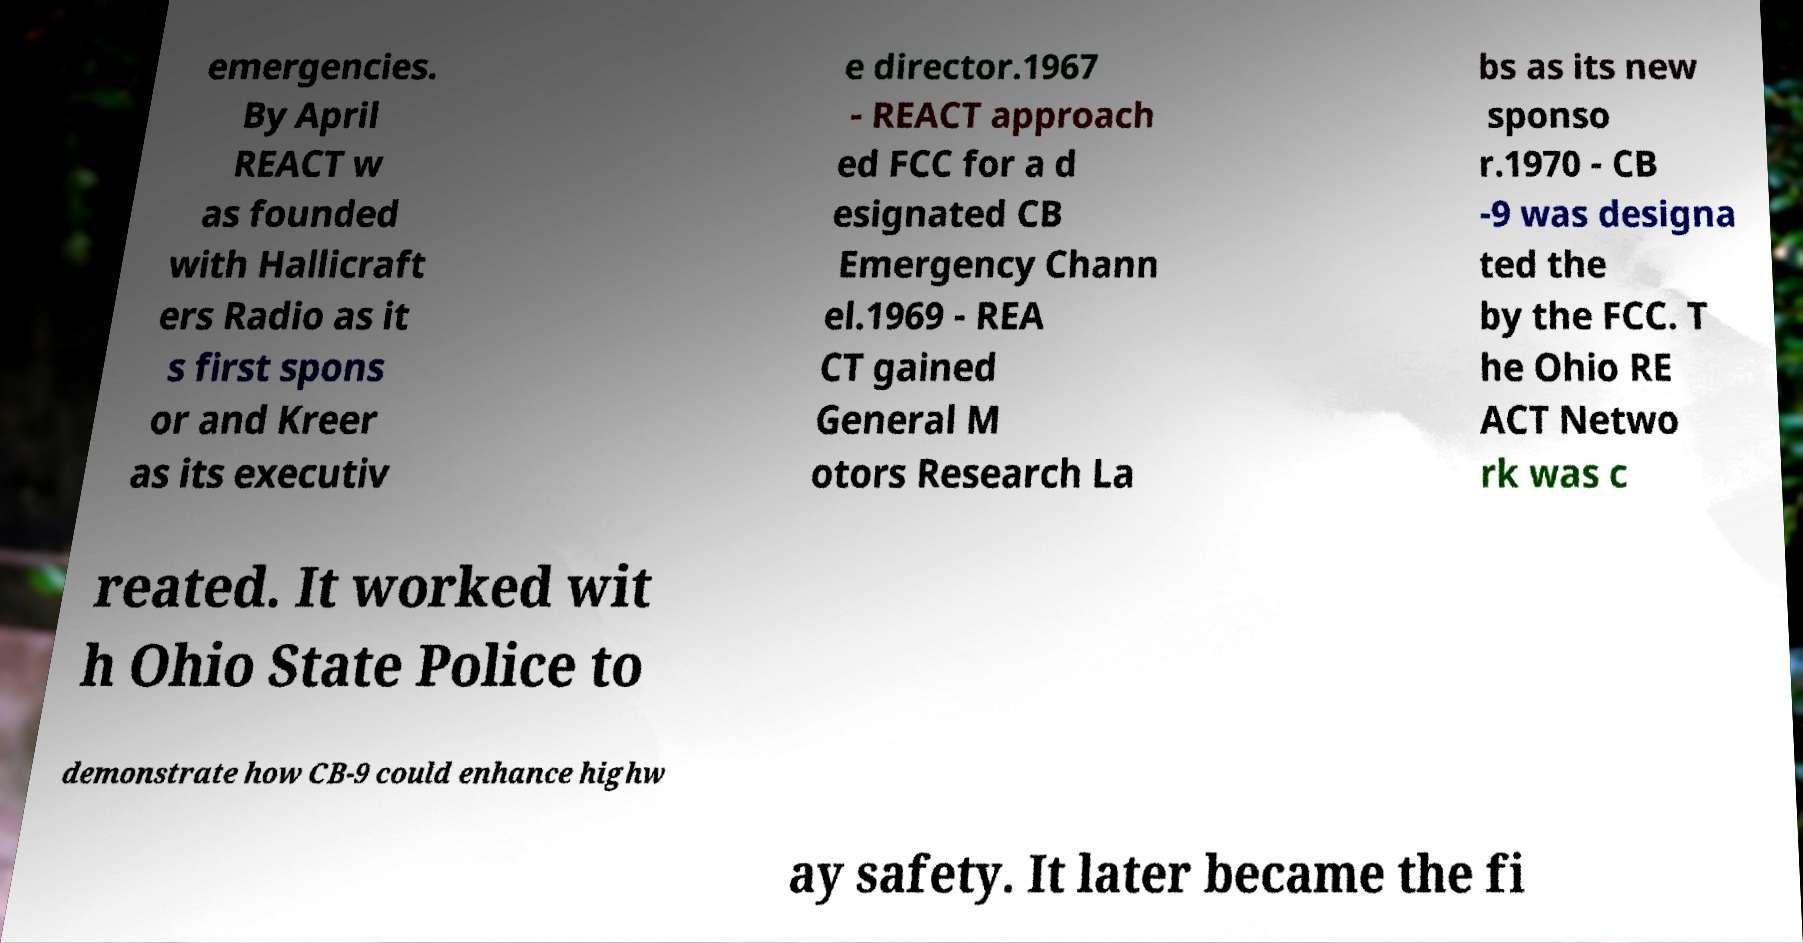There's text embedded in this image that I need extracted. Can you transcribe it verbatim? emergencies. By April REACT w as founded with Hallicraft ers Radio as it s first spons or and Kreer as its executiv e director.1967 - REACT approach ed FCC for a d esignated CB Emergency Chann el.1969 - REA CT gained General M otors Research La bs as its new sponso r.1970 - CB -9 was designa ted the by the FCC. T he Ohio RE ACT Netwo rk was c reated. It worked wit h Ohio State Police to demonstrate how CB-9 could enhance highw ay safety. It later became the fi 